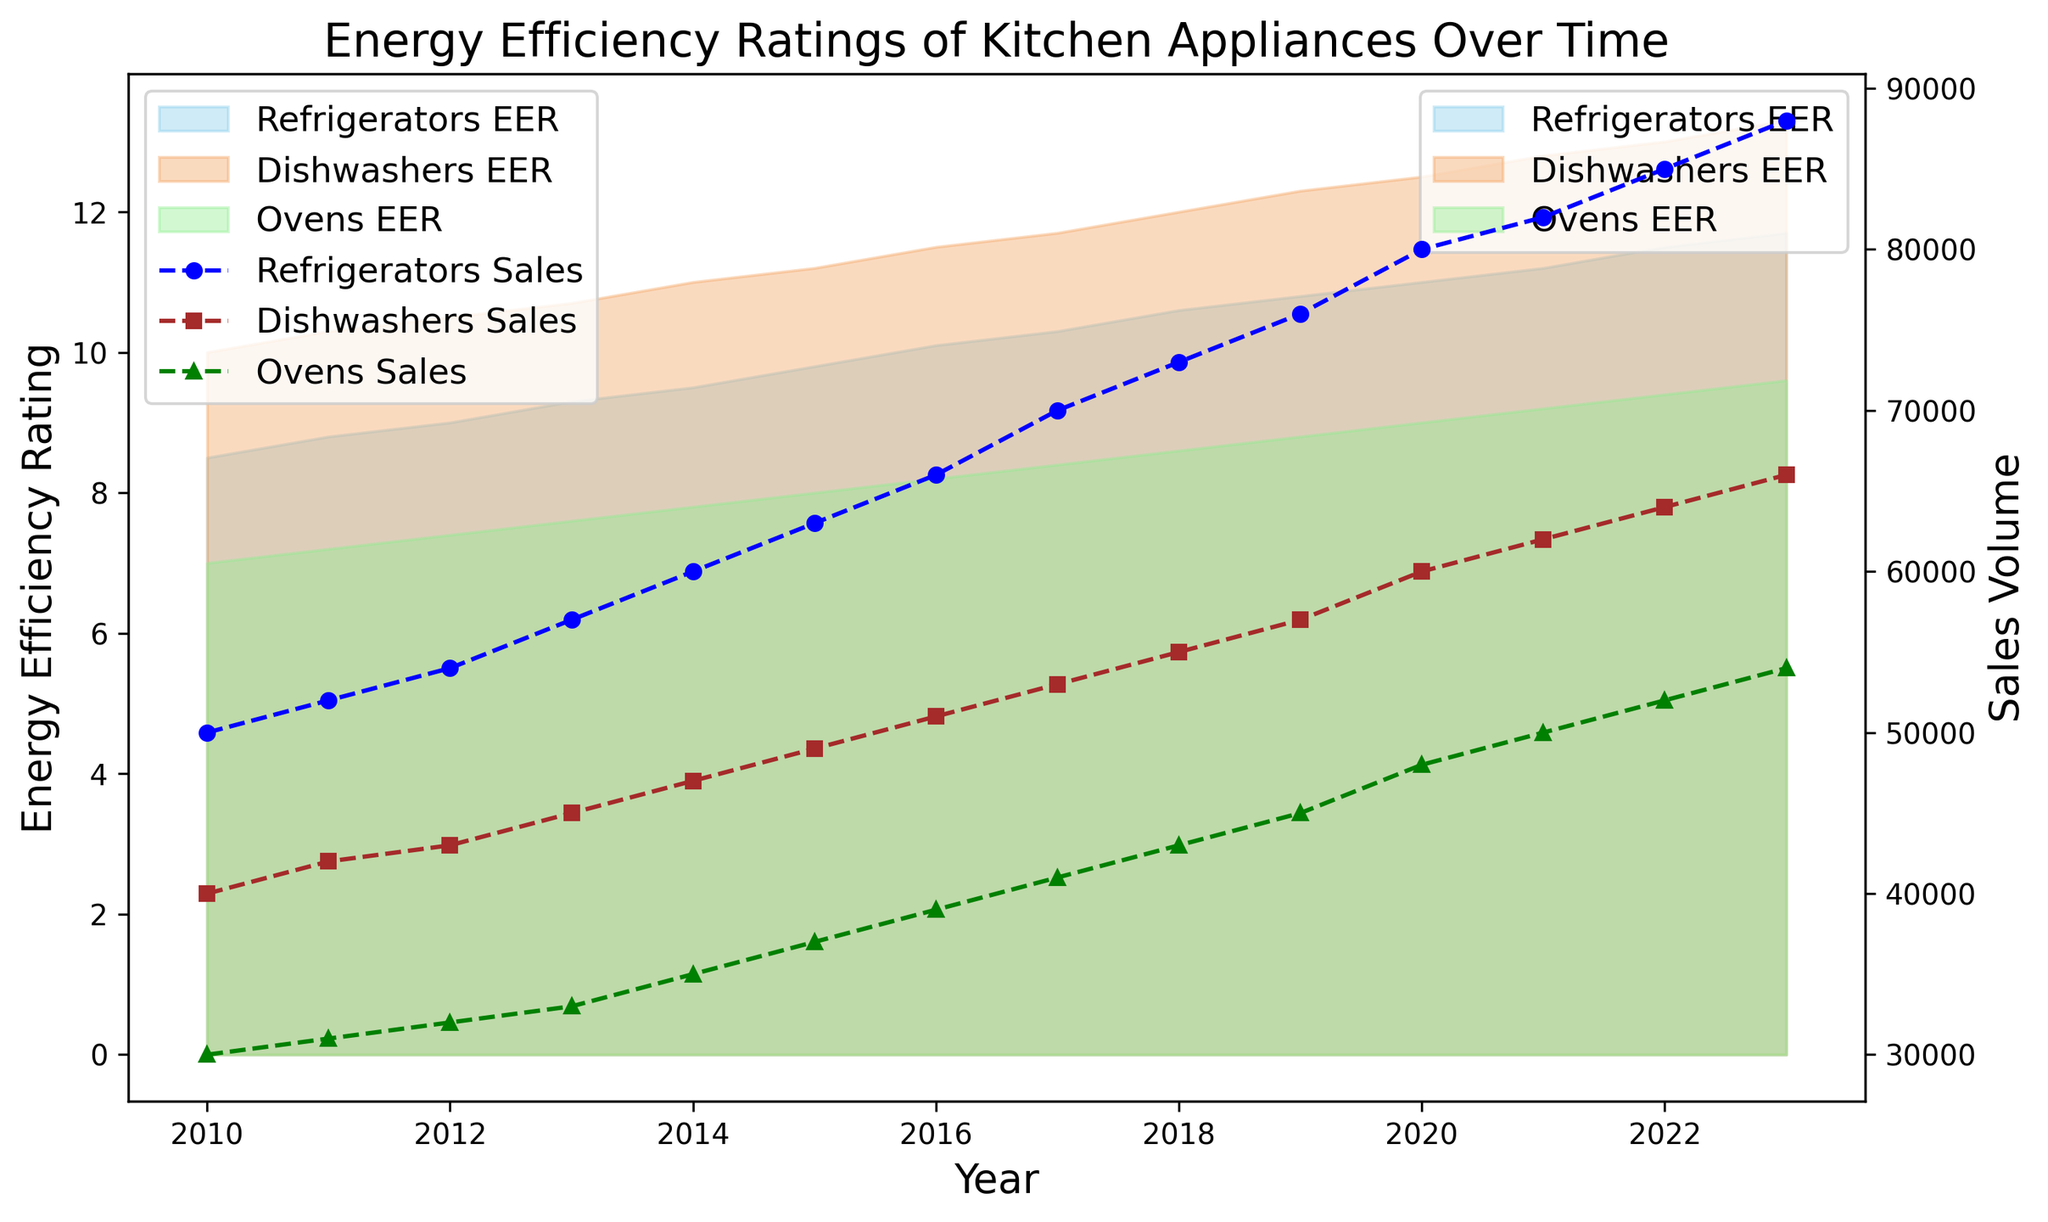What trends are observable for the Energy Efficiency Ratings (EER) of Refrigerators over the years? The EER of Refrigerators shows a consistent upward trend from 8.5 in 2010 to 11.7 in 2023.
Answer: Upward trend What is the difference in the Energy Efficiency Rating (EER) between Ovens and Dishwashers in 2020? In 2020, the EER for Ovens is 9.0 and for Dishwashers is 12.5. The difference is 12.5 - 9.0 = 3.5.
Answer: 3.5 Which appliance shows the highest upward trend in EER from 2010 to 2023? By observing the areas, Dishwashers show the highest upward trend, increasing from 10.0 in 2010 to 13.3 in 2023, a total increase of 3.3.
Answer: Dishwashers How do the sales volumes for Ovens compare to Dishwashers in 2015? In 2015, Ovens have a sales volume of 37,000 units, while Dishwashers have 49,000 units. Ovens' sales are lower.
Answer: Dishwasher sales are higher What is the overall trend for the sales volume of Refrigerators from 2010 to 2023? The sales volume of Refrigerators shows a consistent upward trend from 50,000 units in 2010 to 88,000 units in 2023.
Answer: Upward trend By how much did the Energy Efficiency Rating (EER) for Dishwashers change from 2013 to 2016? The EER for Dishwashers in 2013 is 10.7, and in 2016 it is 11.5. The change is 11.5 - 10.7 = 0.8.
Answer: 0.8 Which year shows the highest Energy Efficiency Rating (EER) for Ovens, and what is the value? The highest EER value for Ovens is shown in 2023, with a value of 9.6.
Answer: 2023, 9.6 What is the combined sales volume for all appliances in 2022? The sales volumes in 2022 are 85,000 (Refrigerators), 64,000 (Dishwashers), and 52,000 (Ovens). The combined sales volume is 85,000 + 64,000 + 52,000 = 201,000.
Answer: 201,000 How does the sales volume trend for Dishwashers compare to Refrigerators from 2010 to 2023? Both Dishwashers and Refrigerators show an upward trend, but Refrigerators' sales increase more significantly from 50,000 to 88,000 compared to Dishwashers' increase from 40,000 to 66,000.
Answer: Refrigerators increased more By what percentage did the sales of Ovens increase from 2010 to 2020? The sales volume for Ovens in 2010 is 30,000, and in 2020 it is 48,000. The increase is 48,000 - 30,000 = 18,000. The percentage increase is (18,000 / 30,000) * 100 = 60%.
Answer: 60% 